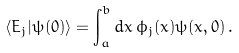<formula> <loc_0><loc_0><loc_500><loc_500>\langle E _ { j } | \psi ( 0 ) \rangle = \int _ { a } ^ { b } d x \, \phi _ { j } ( x ) \psi ( x , 0 ) \, .</formula> 